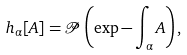<formula> <loc_0><loc_0><loc_500><loc_500>h _ { \alpha } [ A ] = \mathcal { P } \left ( \exp - \int _ { \alpha } A \right ) ,</formula> 